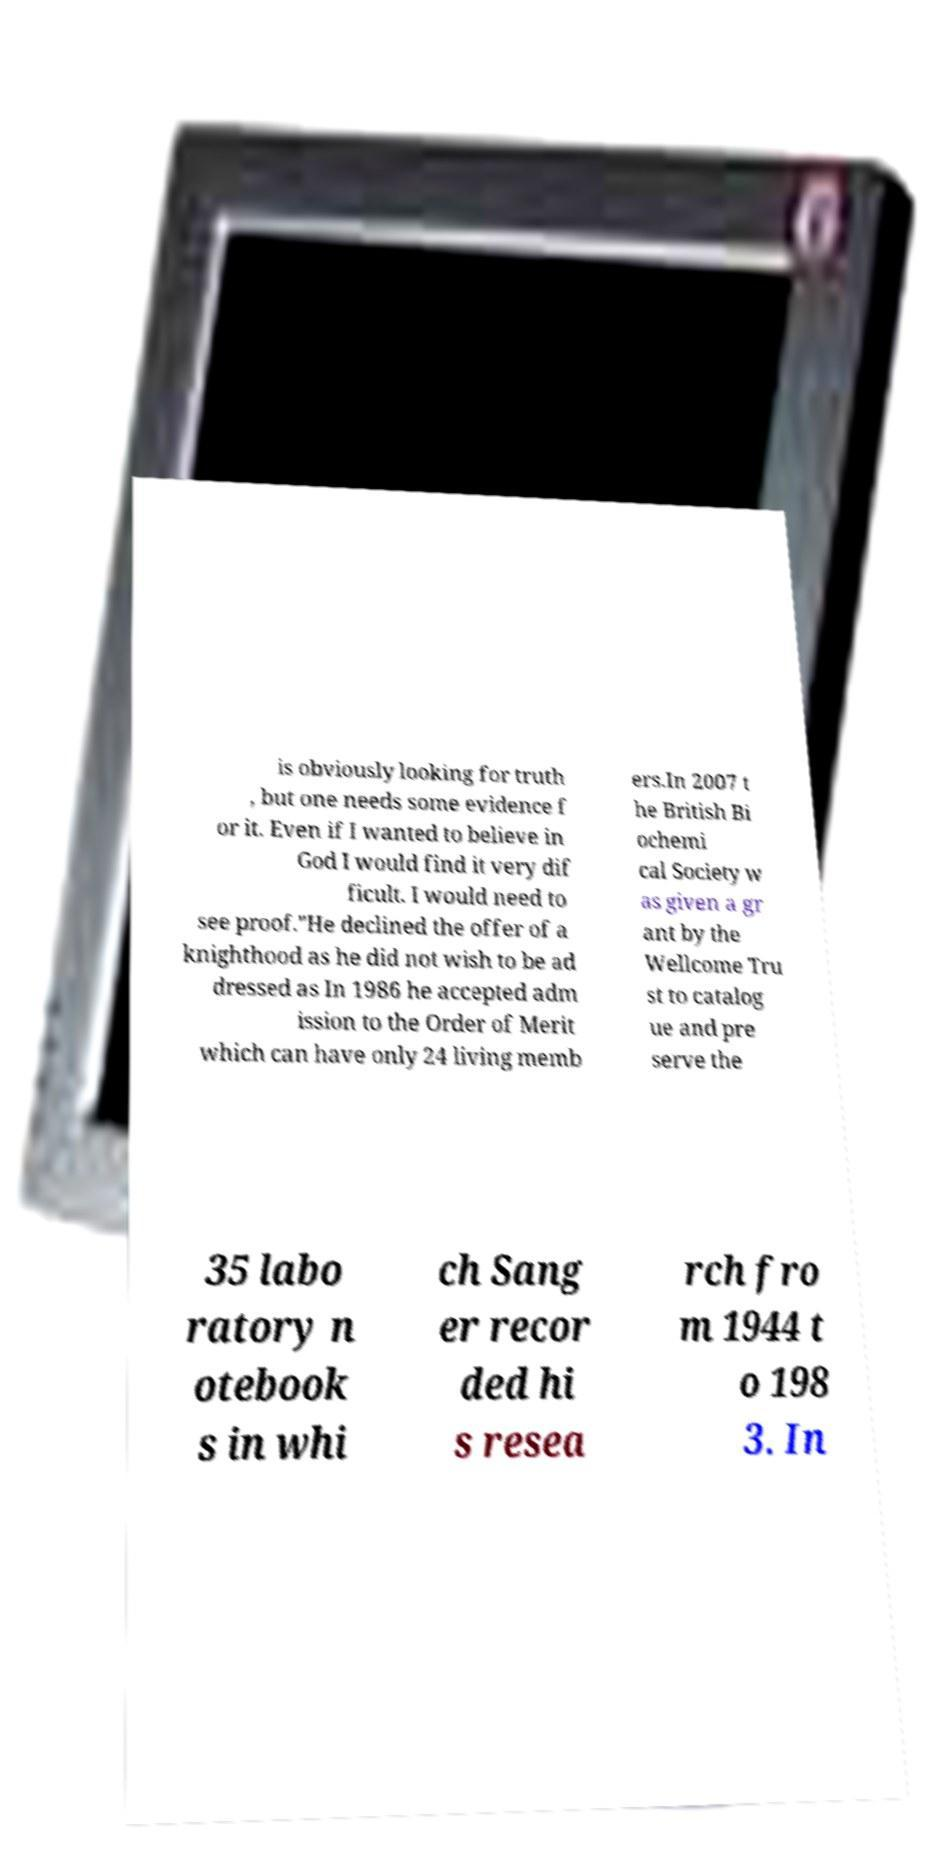What messages or text are displayed in this image? I need them in a readable, typed format. is obviously looking for truth , but one needs some evidence f or it. Even if I wanted to believe in God I would find it very dif ficult. I would need to see proof."He declined the offer of a knighthood as he did not wish to be ad dressed as In 1986 he accepted adm ission to the Order of Merit which can have only 24 living memb ers.In 2007 t he British Bi ochemi cal Society w as given a gr ant by the Wellcome Tru st to catalog ue and pre serve the 35 labo ratory n otebook s in whi ch Sang er recor ded hi s resea rch fro m 1944 t o 198 3. In 